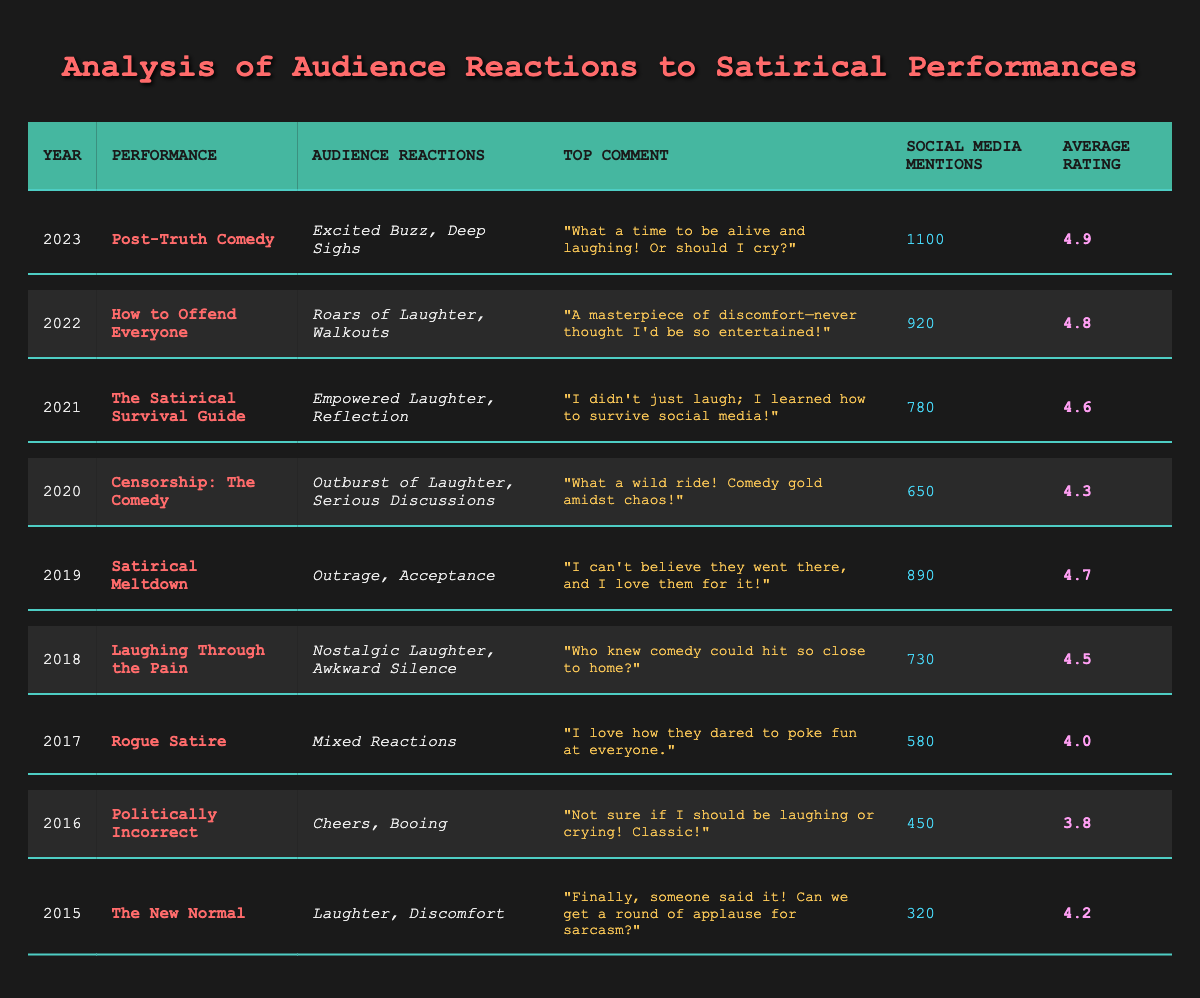What was the performance with the highest average rating? The table shows that "Post-Truth Comedy" in 2023 has the highest average rating of 4.9. I identified the ratings for all performances and noted that 4.9 is the maximum value.
Answer: Post-Truth Comedy Which year had the lowest social media mentions? Looking at the table, "The New Normal" in 2015 had the lowest social media mentions at 320. I scanned through the social media mentions column to find the smallest number.
Answer: 2015 What percentage increase in social media mentions occurred from 2019 to 2020? The mentions in 2019 were 890, and in 2020 they were 650. I calculated the change: 650 - 890 = -240, then found the percentage decrease: (-240/890) * 100 = -26.96%, indicating a decrease.
Answer: -26.96% Which performance had mixed reactions? "Rogue Satire" from 2017 is the performance listed with mixed reactions. I searched the audience reactions column looking for that specific phrase.
Answer: Rogue Satire Was the average rating for "Censorship: The Comedy" higher than 4.0? The average rating for "Censorship: The Comedy" in 2020 is 4.3, which is indeed higher than 4.0. I compared the value directly with 4.0 from the ratings column.
Answer: Yes What is the average rating for performances from 2018 to 2023? The ratings from 2018 to 2023 are 4.5, 4.7, 4.3, 4.6, and 4.9. I summed these ratings (4.5 + 4.7 + 4.3 + 4.6 + 4.9 = 24) and divided by 5 to get the average, which is 24/5 = 4.8.
Answer: 4.8 In which years did audience reactions include "Laughter"? The years with audience reactions that mentioned “Laughter” are 2015 ("The New Normal"), 2018 ("Laughing Through the Pain"), 2019 ("Satirical Meltdown"), 2020 ("Censorship: The Comedy"), 2021 ("The Satirical Survival Guide"), 2022 ("How to Offend Everyone"), and 2023 ("Post-Truth Comedy"). I went through the reactions column and filtered for that term.
Answer: 2015, 2018, 2019, 2020, 2021, 2022, 2023 How many performances received an average rating of 4.5 or higher? The performances with ratings of 4.5 or higher are 2018 (4.5), 2019 (4.7), 2021 (4.6), 2022 (4.8), and 2023 (4.9). I tallied these from the ratings column, yielding 5 performances.
Answer: 5 Did any performance receive boos as part of its audience reactions? Yes, "Politically Incorrect" in 2016 received boos as part of its reactions. I checked the reactions column for the term "Booing."
Answer: Yes Which performance had the most social media mentions and what was the number? The performance with the most social media mentions is "Post-Truth Comedy" in 2023, with 1100 mentions. I looked for the maximum value in the social media mentions column.
Answer: 1100 